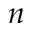Convert formula to latex. <formula><loc_0><loc_0><loc_500><loc_500>n</formula> 